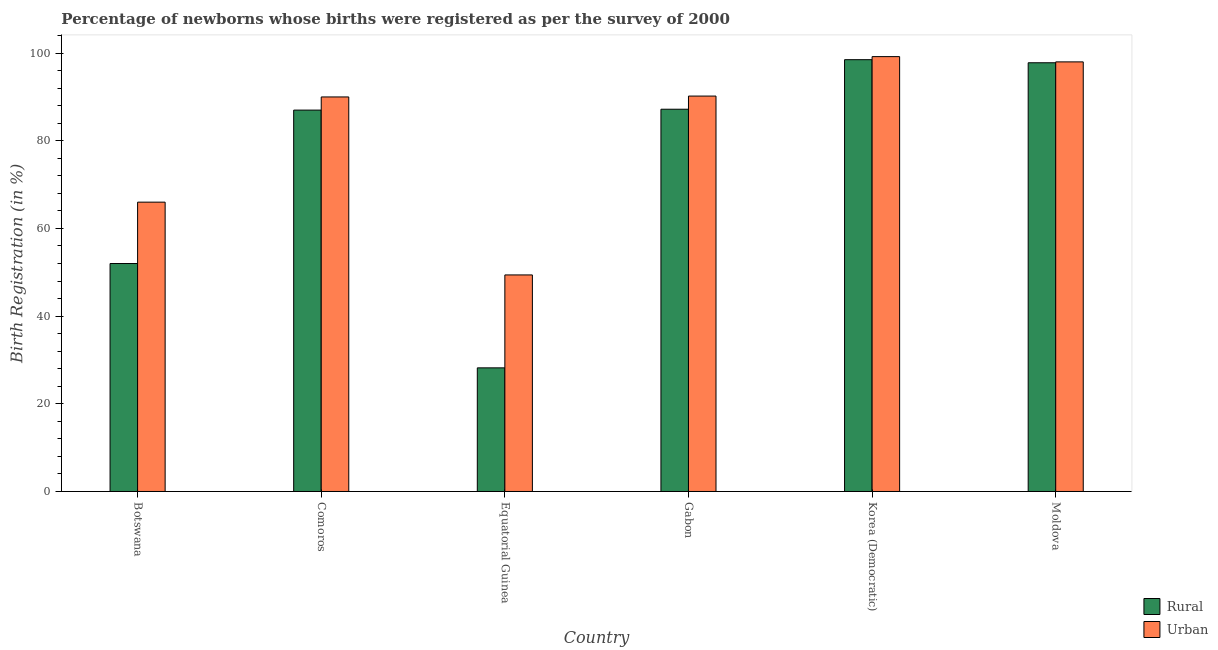How many different coloured bars are there?
Keep it short and to the point. 2. Are the number of bars on each tick of the X-axis equal?
Offer a very short reply. Yes. How many bars are there on the 6th tick from the left?
Ensure brevity in your answer.  2. What is the label of the 3rd group of bars from the left?
Offer a terse response. Equatorial Guinea. What is the rural birth registration in Gabon?
Offer a terse response. 87.2. Across all countries, what is the maximum rural birth registration?
Your answer should be very brief. 98.5. Across all countries, what is the minimum urban birth registration?
Your response must be concise. 49.4. In which country was the urban birth registration maximum?
Make the answer very short. Korea (Democratic). In which country was the urban birth registration minimum?
Your answer should be very brief. Equatorial Guinea. What is the total rural birth registration in the graph?
Ensure brevity in your answer.  450.7. What is the difference between the rural birth registration in Botswana and that in Gabon?
Your response must be concise. -35.2. What is the difference between the urban birth registration in Korea (Democratic) and the rural birth registration in Equatorial Guinea?
Your response must be concise. 71. What is the average rural birth registration per country?
Keep it short and to the point. 75.12. What is the difference between the rural birth registration and urban birth registration in Korea (Democratic)?
Your response must be concise. -0.7. In how many countries, is the rural birth registration greater than 76 %?
Keep it short and to the point. 4. What is the ratio of the urban birth registration in Gabon to that in Korea (Democratic)?
Your answer should be compact. 0.91. Is the rural birth registration in Equatorial Guinea less than that in Korea (Democratic)?
Offer a very short reply. Yes. What is the difference between the highest and the second highest urban birth registration?
Your answer should be compact. 1.2. What is the difference between the highest and the lowest rural birth registration?
Ensure brevity in your answer.  70.3. In how many countries, is the rural birth registration greater than the average rural birth registration taken over all countries?
Your answer should be compact. 4. Is the sum of the rural birth registration in Botswana and Moldova greater than the maximum urban birth registration across all countries?
Provide a succinct answer. Yes. What does the 1st bar from the left in Gabon represents?
Offer a very short reply. Rural. What does the 1st bar from the right in Botswana represents?
Provide a short and direct response. Urban. Are all the bars in the graph horizontal?
Keep it short and to the point. No. What is the difference between two consecutive major ticks on the Y-axis?
Keep it short and to the point. 20. Are the values on the major ticks of Y-axis written in scientific E-notation?
Ensure brevity in your answer.  No. Does the graph contain any zero values?
Keep it short and to the point. No. Does the graph contain grids?
Offer a very short reply. No. What is the title of the graph?
Your response must be concise. Percentage of newborns whose births were registered as per the survey of 2000. What is the label or title of the X-axis?
Your response must be concise. Country. What is the label or title of the Y-axis?
Provide a succinct answer. Birth Registration (in %). What is the Birth Registration (in %) in Urban in Botswana?
Keep it short and to the point. 66. What is the Birth Registration (in %) of Rural in Comoros?
Keep it short and to the point. 87. What is the Birth Registration (in %) of Urban in Comoros?
Provide a succinct answer. 90. What is the Birth Registration (in %) of Rural in Equatorial Guinea?
Offer a very short reply. 28.2. What is the Birth Registration (in %) of Urban in Equatorial Guinea?
Provide a short and direct response. 49.4. What is the Birth Registration (in %) in Rural in Gabon?
Offer a terse response. 87.2. What is the Birth Registration (in %) in Urban in Gabon?
Give a very brief answer. 90.2. What is the Birth Registration (in %) of Rural in Korea (Democratic)?
Give a very brief answer. 98.5. What is the Birth Registration (in %) of Urban in Korea (Democratic)?
Offer a terse response. 99.2. What is the Birth Registration (in %) in Rural in Moldova?
Your response must be concise. 97.8. Across all countries, what is the maximum Birth Registration (in %) of Rural?
Provide a succinct answer. 98.5. Across all countries, what is the maximum Birth Registration (in %) in Urban?
Offer a terse response. 99.2. Across all countries, what is the minimum Birth Registration (in %) in Rural?
Provide a short and direct response. 28.2. Across all countries, what is the minimum Birth Registration (in %) in Urban?
Give a very brief answer. 49.4. What is the total Birth Registration (in %) of Rural in the graph?
Provide a succinct answer. 450.7. What is the total Birth Registration (in %) of Urban in the graph?
Provide a succinct answer. 492.8. What is the difference between the Birth Registration (in %) in Rural in Botswana and that in Comoros?
Offer a very short reply. -35. What is the difference between the Birth Registration (in %) of Rural in Botswana and that in Equatorial Guinea?
Keep it short and to the point. 23.8. What is the difference between the Birth Registration (in %) in Urban in Botswana and that in Equatorial Guinea?
Your answer should be very brief. 16.6. What is the difference between the Birth Registration (in %) of Rural in Botswana and that in Gabon?
Make the answer very short. -35.2. What is the difference between the Birth Registration (in %) in Urban in Botswana and that in Gabon?
Make the answer very short. -24.2. What is the difference between the Birth Registration (in %) in Rural in Botswana and that in Korea (Democratic)?
Offer a terse response. -46.5. What is the difference between the Birth Registration (in %) of Urban in Botswana and that in Korea (Democratic)?
Provide a succinct answer. -33.2. What is the difference between the Birth Registration (in %) of Rural in Botswana and that in Moldova?
Give a very brief answer. -45.8. What is the difference between the Birth Registration (in %) of Urban in Botswana and that in Moldova?
Give a very brief answer. -32. What is the difference between the Birth Registration (in %) of Rural in Comoros and that in Equatorial Guinea?
Offer a terse response. 58.8. What is the difference between the Birth Registration (in %) of Urban in Comoros and that in Equatorial Guinea?
Ensure brevity in your answer.  40.6. What is the difference between the Birth Registration (in %) in Rural in Comoros and that in Korea (Democratic)?
Provide a short and direct response. -11.5. What is the difference between the Birth Registration (in %) in Urban in Comoros and that in Korea (Democratic)?
Your answer should be very brief. -9.2. What is the difference between the Birth Registration (in %) in Rural in Comoros and that in Moldova?
Ensure brevity in your answer.  -10.8. What is the difference between the Birth Registration (in %) in Rural in Equatorial Guinea and that in Gabon?
Offer a terse response. -59. What is the difference between the Birth Registration (in %) in Urban in Equatorial Guinea and that in Gabon?
Your answer should be compact. -40.8. What is the difference between the Birth Registration (in %) of Rural in Equatorial Guinea and that in Korea (Democratic)?
Provide a succinct answer. -70.3. What is the difference between the Birth Registration (in %) of Urban in Equatorial Guinea and that in Korea (Democratic)?
Your answer should be compact. -49.8. What is the difference between the Birth Registration (in %) in Rural in Equatorial Guinea and that in Moldova?
Your answer should be very brief. -69.6. What is the difference between the Birth Registration (in %) of Urban in Equatorial Guinea and that in Moldova?
Provide a short and direct response. -48.6. What is the difference between the Birth Registration (in %) of Rural in Gabon and that in Korea (Democratic)?
Your answer should be very brief. -11.3. What is the difference between the Birth Registration (in %) of Urban in Gabon and that in Moldova?
Your answer should be very brief. -7.8. What is the difference between the Birth Registration (in %) of Urban in Korea (Democratic) and that in Moldova?
Make the answer very short. 1.2. What is the difference between the Birth Registration (in %) of Rural in Botswana and the Birth Registration (in %) of Urban in Comoros?
Ensure brevity in your answer.  -38. What is the difference between the Birth Registration (in %) in Rural in Botswana and the Birth Registration (in %) in Urban in Equatorial Guinea?
Give a very brief answer. 2.6. What is the difference between the Birth Registration (in %) in Rural in Botswana and the Birth Registration (in %) in Urban in Gabon?
Provide a succinct answer. -38.2. What is the difference between the Birth Registration (in %) in Rural in Botswana and the Birth Registration (in %) in Urban in Korea (Democratic)?
Give a very brief answer. -47.2. What is the difference between the Birth Registration (in %) of Rural in Botswana and the Birth Registration (in %) of Urban in Moldova?
Give a very brief answer. -46. What is the difference between the Birth Registration (in %) of Rural in Comoros and the Birth Registration (in %) of Urban in Equatorial Guinea?
Your answer should be compact. 37.6. What is the difference between the Birth Registration (in %) in Rural in Comoros and the Birth Registration (in %) in Urban in Gabon?
Provide a short and direct response. -3.2. What is the difference between the Birth Registration (in %) in Rural in Comoros and the Birth Registration (in %) in Urban in Korea (Democratic)?
Your response must be concise. -12.2. What is the difference between the Birth Registration (in %) of Rural in Comoros and the Birth Registration (in %) of Urban in Moldova?
Ensure brevity in your answer.  -11. What is the difference between the Birth Registration (in %) in Rural in Equatorial Guinea and the Birth Registration (in %) in Urban in Gabon?
Offer a terse response. -62. What is the difference between the Birth Registration (in %) of Rural in Equatorial Guinea and the Birth Registration (in %) of Urban in Korea (Democratic)?
Your answer should be compact. -71. What is the difference between the Birth Registration (in %) of Rural in Equatorial Guinea and the Birth Registration (in %) of Urban in Moldova?
Make the answer very short. -69.8. What is the difference between the Birth Registration (in %) of Rural in Gabon and the Birth Registration (in %) of Urban in Moldova?
Offer a terse response. -10.8. What is the difference between the Birth Registration (in %) in Rural in Korea (Democratic) and the Birth Registration (in %) in Urban in Moldova?
Your answer should be compact. 0.5. What is the average Birth Registration (in %) of Rural per country?
Give a very brief answer. 75.12. What is the average Birth Registration (in %) in Urban per country?
Offer a terse response. 82.13. What is the difference between the Birth Registration (in %) in Rural and Birth Registration (in %) in Urban in Botswana?
Offer a very short reply. -14. What is the difference between the Birth Registration (in %) in Rural and Birth Registration (in %) in Urban in Equatorial Guinea?
Ensure brevity in your answer.  -21.2. What is the difference between the Birth Registration (in %) of Rural and Birth Registration (in %) of Urban in Gabon?
Offer a very short reply. -3. What is the difference between the Birth Registration (in %) of Rural and Birth Registration (in %) of Urban in Moldova?
Provide a short and direct response. -0.2. What is the ratio of the Birth Registration (in %) of Rural in Botswana to that in Comoros?
Make the answer very short. 0.6. What is the ratio of the Birth Registration (in %) of Urban in Botswana to that in Comoros?
Your response must be concise. 0.73. What is the ratio of the Birth Registration (in %) of Rural in Botswana to that in Equatorial Guinea?
Your answer should be compact. 1.84. What is the ratio of the Birth Registration (in %) of Urban in Botswana to that in Equatorial Guinea?
Offer a terse response. 1.34. What is the ratio of the Birth Registration (in %) in Rural in Botswana to that in Gabon?
Provide a succinct answer. 0.6. What is the ratio of the Birth Registration (in %) of Urban in Botswana to that in Gabon?
Provide a succinct answer. 0.73. What is the ratio of the Birth Registration (in %) in Rural in Botswana to that in Korea (Democratic)?
Your answer should be compact. 0.53. What is the ratio of the Birth Registration (in %) of Urban in Botswana to that in Korea (Democratic)?
Your answer should be very brief. 0.67. What is the ratio of the Birth Registration (in %) in Rural in Botswana to that in Moldova?
Keep it short and to the point. 0.53. What is the ratio of the Birth Registration (in %) of Urban in Botswana to that in Moldova?
Your answer should be compact. 0.67. What is the ratio of the Birth Registration (in %) in Rural in Comoros to that in Equatorial Guinea?
Make the answer very short. 3.09. What is the ratio of the Birth Registration (in %) of Urban in Comoros to that in Equatorial Guinea?
Your response must be concise. 1.82. What is the ratio of the Birth Registration (in %) in Rural in Comoros to that in Gabon?
Offer a very short reply. 1. What is the ratio of the Birth Registration (in %) in Rural in Comoros to that in Korea (Democratic)?
Provide a short and direct response. 0.88. What is the ratio of the Birth Registration (in %) of Urban in Comoros to that in Korea (Democratic)?
Ensure brevity in your answer.  0.91. What is the ratio of the Birth Registration (in %) in Rural in Comoros to that in Moldova?
Keep it short and to the point. 0.89. What is the ratio of the Birth Registration (in %) of Urban in Comoros to that in Moldova?
Offer a very short reply. 0.92. What is the ratio of the Birth Registration (in %) in Rural in Equatorial Guinea to that in Gabon?
Ensure brevity in your answer.  0.32. What is the ratio of the Birth Registration (in %) of Urban in Equatorial Guinea to that in Gabon?
Offer a very short reply. 0.55. What is the ratio of the Birth Registration (in %) of Rural in Equatorial Guinea to that in Korea (Democratic)?
Make the answer very short. 0.29. What is the ratio of the Birth Registration (in %) in Urban in Equatorial Guinea to that in Korea (Democratic)?
Your response must be concise. 0.5. What is the ratio of the Birth Registration (in %) in Rural in Equatorial Guinea to that in Moldova?
Make the answer very short. 0.29. What is the ratio of the Birth Registration (in %) in Urban in Equatorial Guinea to that in Moldova?
Ensure brevity in your answer.  0.5. What is the ratio of the Birth Registration (in %) in Rural in Gabon to that in Korea (Democratic)?
Offer a very short reply. 0.89. What is the ratio of the Birth Registration (in %) of Urban in Gabon to that in Korea (Democratic)?
Provide a succinct answer. 0.91. What is the ratio of the Birth Registration (in %) in Rural in Gabon to that in Moldova?
Ensure brevity in your answer.  0.89. What is the ratio of the Birth Registration (in %) of Urban in Gabon to that in Moldova?
Ensure brevity in your answer.  0.92. What is the ratio of the Birth Registration (in %) of Urban in Korea (Democratic) to that in Moldova?
Ensure brevity in your answer.  1.01. What is the difference between the highest and the second highest Birth Registration (in %) in Urban?
Keep it short and to the point. 1.2. What is the difference between the highest and the lowest Birth Registration (in %) in Rural?
Make the answer very short. 70.3. What is the difference between the highest and the lowest Birth Registration (in %) of Urban?
Keep it short and to the point. 49.8. 